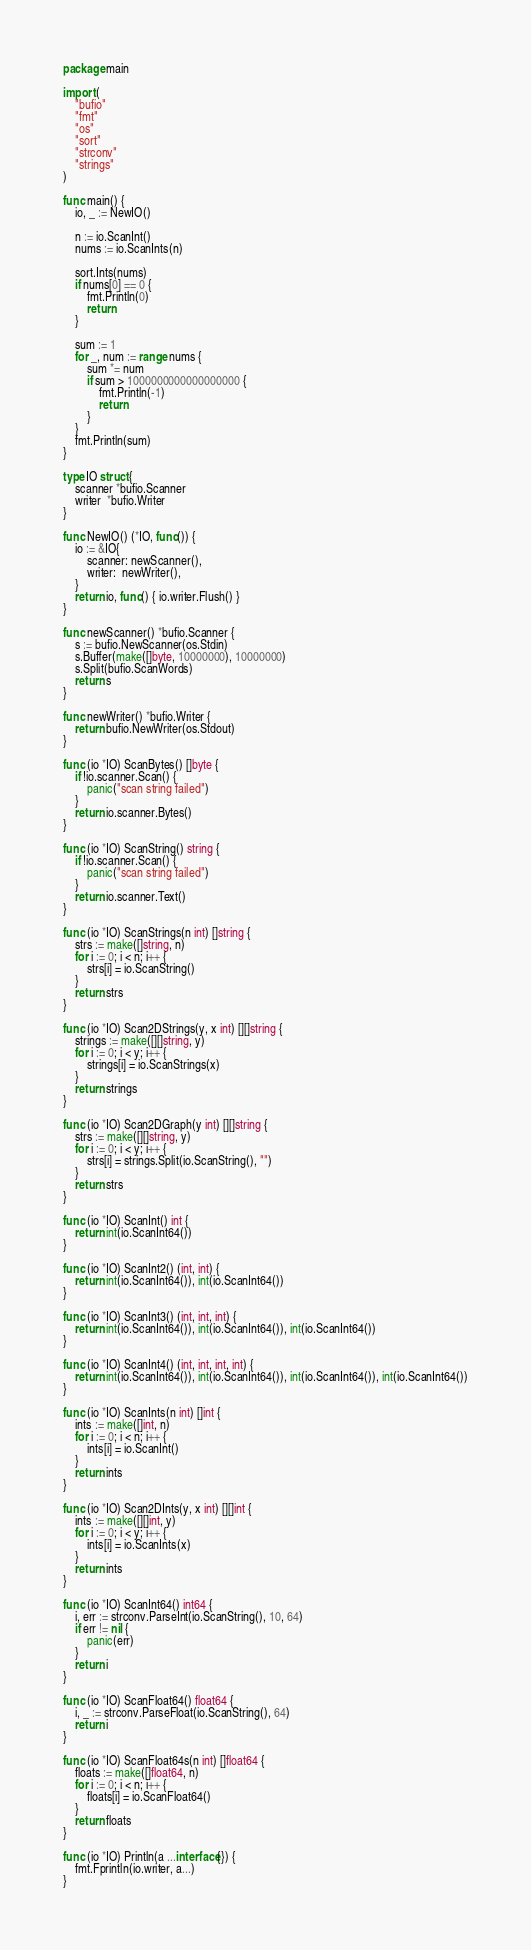Convert code to text. <code><loc_0><loc_0><loc_500><loc_500><_Go_>package main

import (
	"bufio"
	"fmt"
	"os"
	"sort"
	"strconv"
	"strings"
)

func main() {
	io, _ := NewIO()

	n := io.ScanInt()
	nums := io.ScanInts(n)

	sort.Ints(nums)
	if nums[0] == 0 {
		fmt.Println(0)
		return
	}

	sum := 1
	for _, num := range nums {
		sum *= num
		if sum > 1000000000000000000 {
			fmt.Println(-1)
			return
		}
	}
	fmt.Println(sum)
}

type IO struct {
	scanner *bufio.Scanner
	writer  *bufio.Writer
}

func NewIO() (*IO, func()) {
	io := &IO{
		scanner: newScanner(),
		writer:  newWriter(),
	}
	return io, func() { io.writer.Flush() }
}

func newScanner() *bufio.Scanner {
	s := bufio.NewScanner(os.Stdin)
	s.Buffer(make([]byte, 10000000), 10000000)
	s.Split(bufio.ScanWords)
	return s
}

func newWriter() *bufio.Writer {
	return bufio.NewWriter(os.Stdout)
}

func (io *IO) ScanBytes() []byte {
	if !io.scanner.Scan() {
		panic("scan string failed")
	}
	return io.scanner.Bytes()
}

func (io *IO) ScanString() string {
	if !io.scanner.Scan() {
		panic("scan string failed")
	}
	return io.scanner.Text()
}

func (io *IO) ScanStrings(n int) []string {
	strs := make([]string, n)
	for i := 0; i < n; i++ {
		strs[i] = io.ScanString()
	}
	return strs
}

func (io *IO) Scan2DStrings(y, x int) [][]string {
	strings := make([][]string, y)
	for i := 0; i < y; i++ {
		strings[i] = io.ScanStrings(x)
	}
	return strings
}

func (io *IO) Scan2DGraph(y int) [][]string {
	strs := make([][]string, y)
	for i := 0; i < y; i++ {
		strs[i] = strings.Split(io.ScanString(), "")
	}
	return strs
}

func (io *IO) ScanInt() int {
	return int(io.ScanInt64())
}

func (io *IO) ScanInt2() (int, int) {
	return int(io.ScanInt64()), int(io.ScanInt64())
}

func (io *IO) ScanInt3() (int, int, int) {
	return int(io.ScanInt64()), int(io.ScanInt64()), int(io.ScanInt64())
}

func (io *IO) ScanInt4() (int, int, int, int) {
	return int(io.ScanInt64()), int(io.ScanInt64()), int(io.ScanInt64()), int(io.ScanInt64())
}

func (io *IO) ScanInts(n int) []int {
	ints := make([]int, n)
	for i := 0; i < n; i++ {
		ints[i] = io.ScanInt()
	}
	return ints
}

func (io *IO) Scan2DInts(y, x int) [][]int {
	ints := make([][]int, y)
	for i := 0; i < y; i++ {
		ints[i] = io.ScanInts(x)
	}
	return ints
}

func (io *IO) ScanInt64() int64 {
	i, err := strconv.ParseInt(io.ScanString(), 10, 64)
	if err != nil {
		panic(err)
	}
	return i
}

func (io *IO) ScanFloat64() float64 {
	i, _ := strconv.ParseFloat(io.ScanString(), 64)
	return i
}

func (io *IO) ScanFloat64s(n int) []float64 {
	floats := make([]float64, n)
	for i := 0; i < n; i++ {
		floats[i] = io.ScanFloat64()
	}
	return floats
}

func (io *IO) Println(a ...interface{}) {
	fmt.Fprintln(io.writer, a...)
}
</code> 